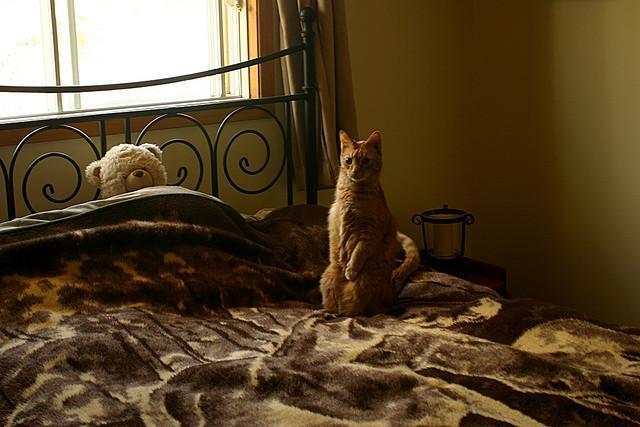How many teddy bears are there?
Give a very brief answer. 1. How many people in the background wears in yellow?
Give a very brief answer. 0. 